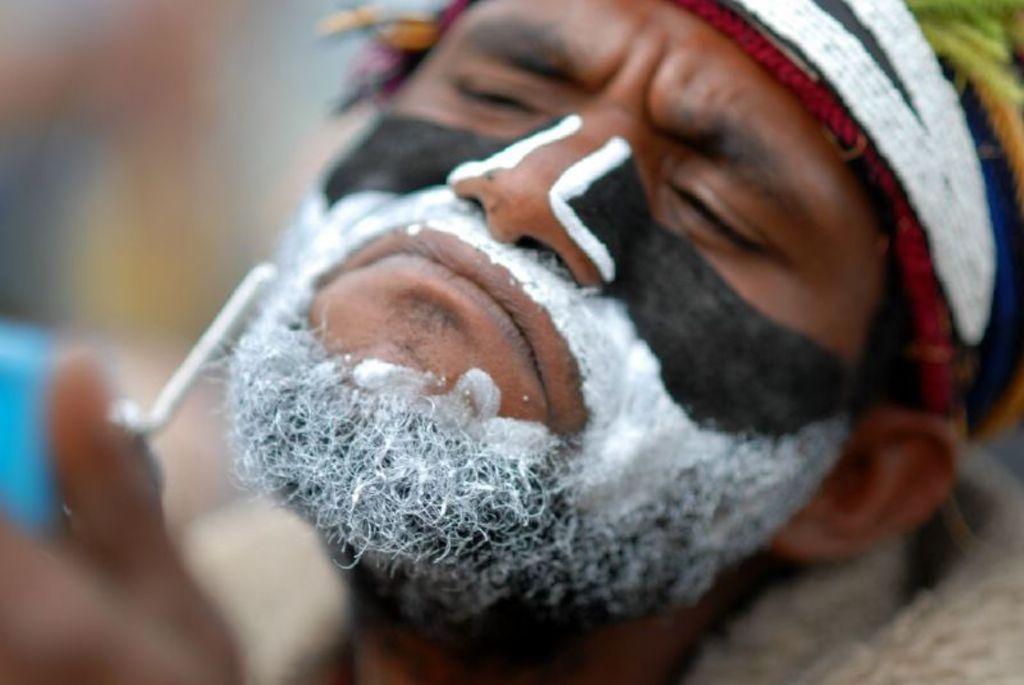How would you summarize this image in a sentence or two? In the image there is a man with black and white color painting on him. And there is a blur image in the background. 